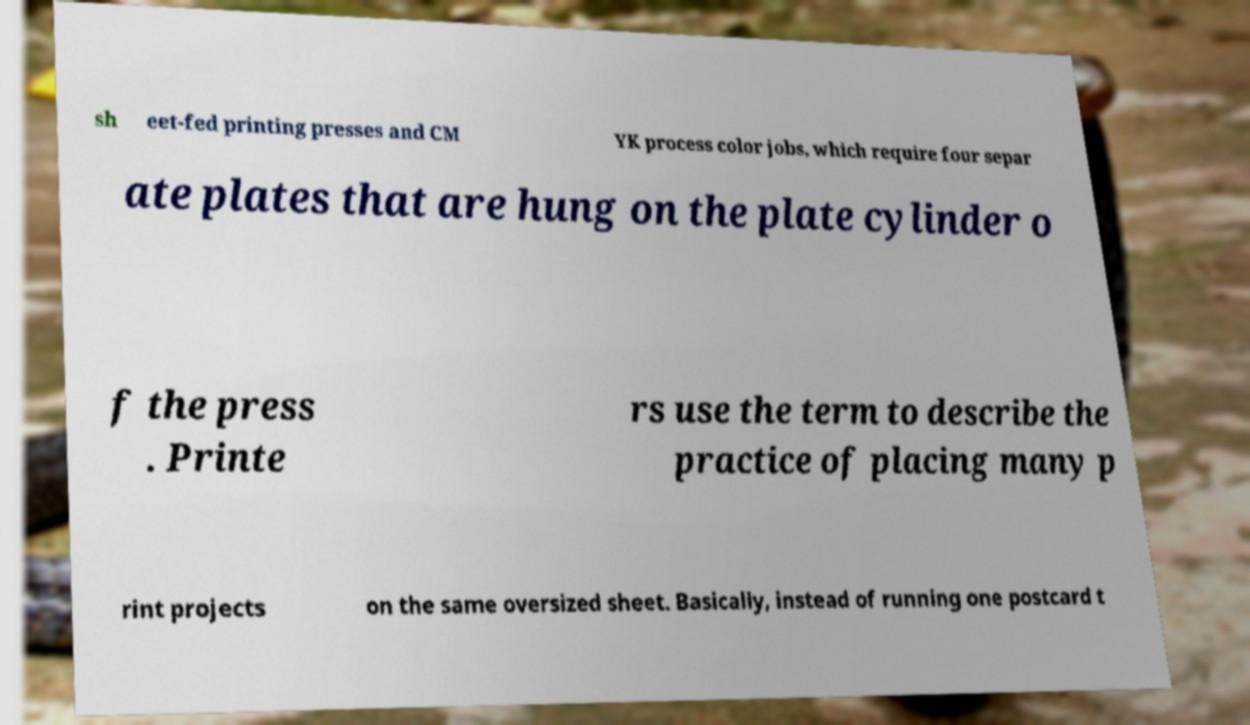There's text embedded in this image that I need extracted. Can you transcribe it verbatim? sh eet-fed printing presses and CM YK process color jobs, which require four separ ate plates that are hung on the plate cylinder o f the press . Printe rs use the term to describe the practice of placing many p rint projects on the same oversized sheet. Basically, instead of running one postcard t 